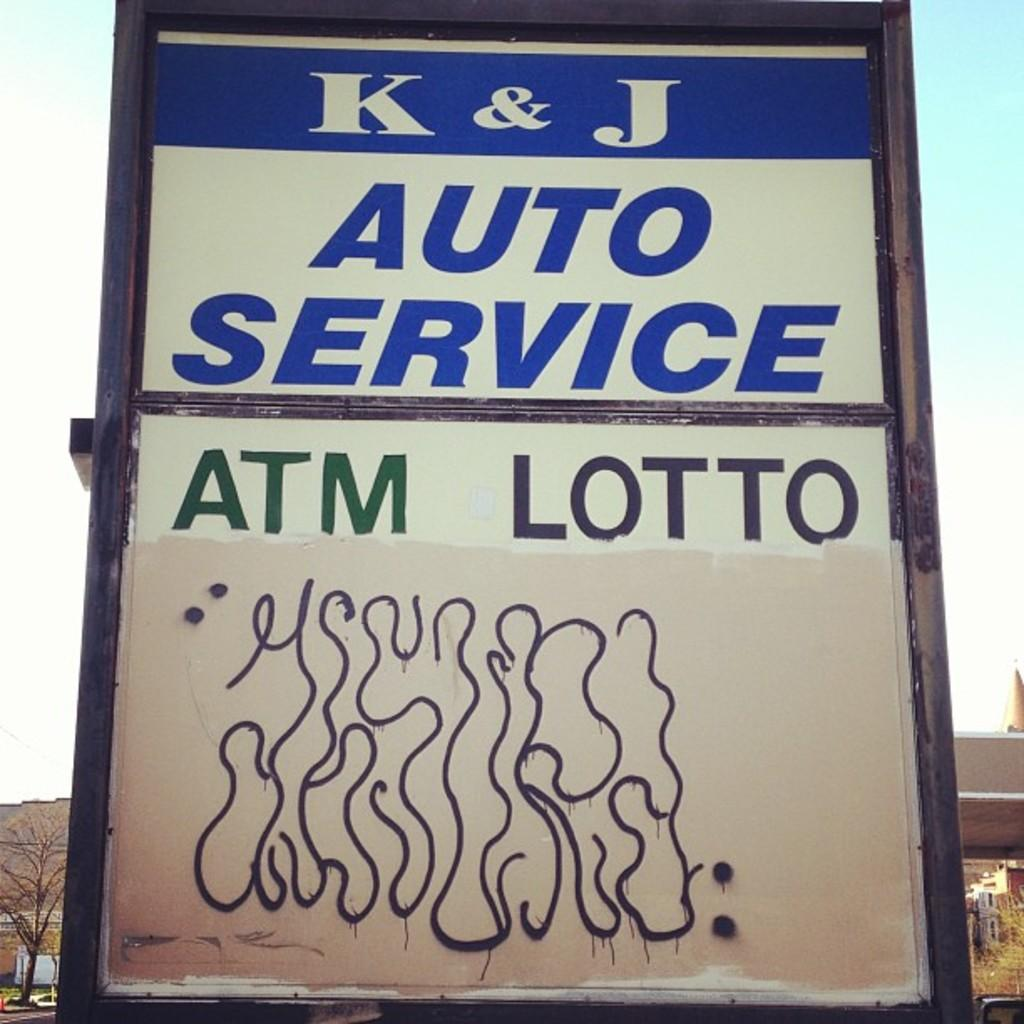What is the main object in the image? There is a display board in the image. What information is displayed on the board? The display board has the text "K & J Auto services and A T M lotto" on it. What type of beast can be seen interacting with the display board in the image? There is no beast present in the image; it only features the display board with text. 